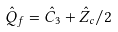<formula> <loc_0><loc_0><loc_500><loc_500>\hat { Q } _ { f } = \hat { C } _ { 3 } + \hat { Z } _ { c } / 2</formula> 